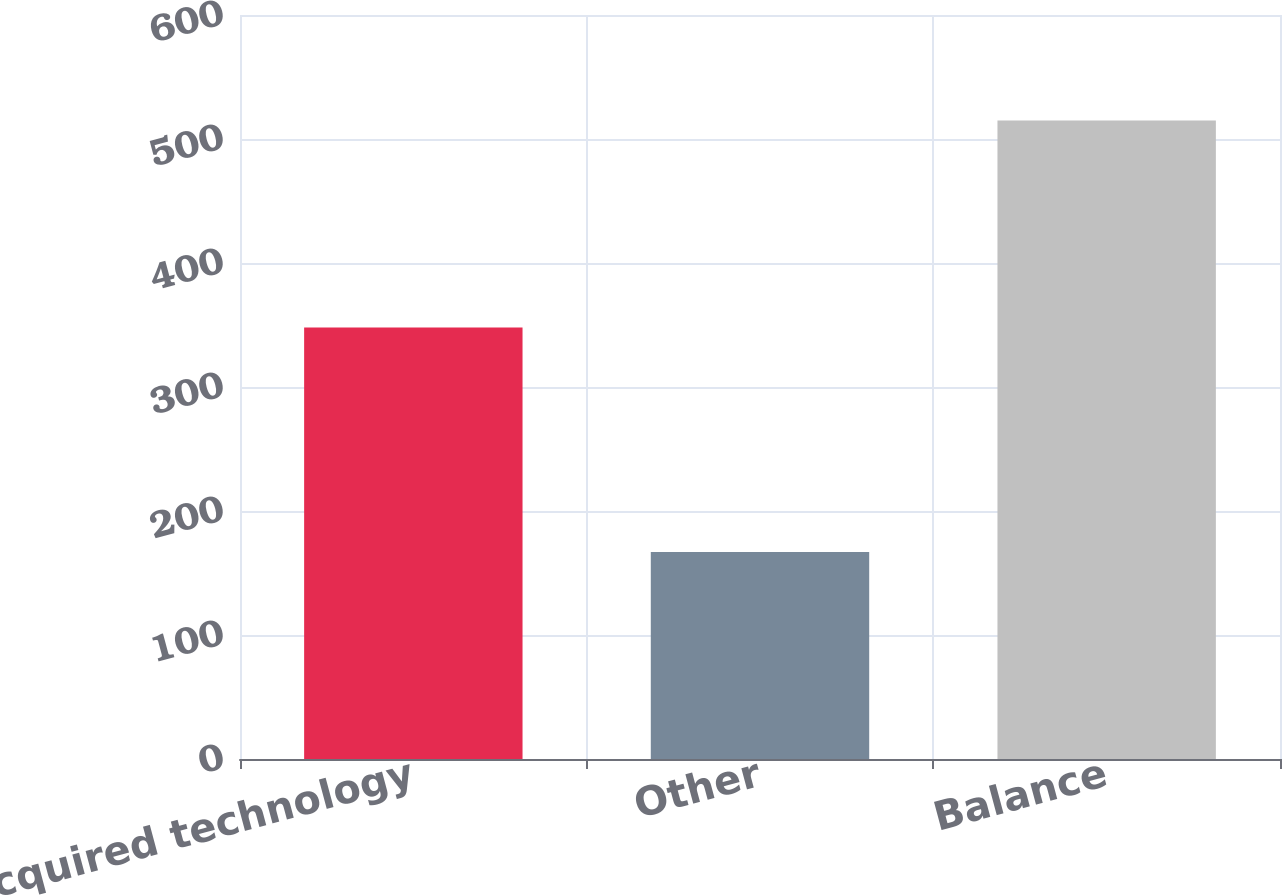<chart> <loc_0><loc_0><loc_500><loc_500><bar_chart><fcel>Acquired technology<fcel>Other<fcel>Balance<nl><fcel>348<fcel>167<fcel>515<nl></chart> 